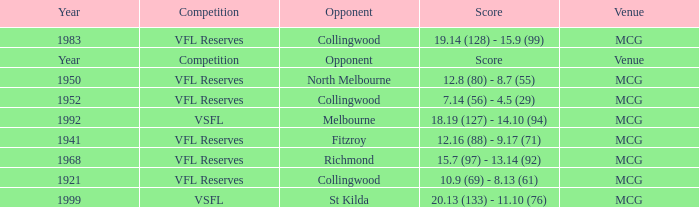At what venue did the team from Collingwood score 7.14 (56) - 4.5 (29)? MCG. Would you mind parsing the complete table? {'header': ['Year', 'Competition', 'Opponent', 'Score', 'Venue'], 'rows': [['1983', 'VFL Reserves', 'Collingwood', '19.14 (128) - 15.9 (99)', 'MCG'], ['Year', 'Competition', 'Opponent', 'Score', 'Venue'], ['1950', 'VFL Reserves', 'North Melbourne', '12.8 (80) - 8.7 (55)', 'MCG'], ['1952', 'VFL Reserves', 'Collingwood', '7.14 (56) - 4.5 (29)', 'MCG'], ['1992', 'VSFL', 'Melbourne', '18.19 (127) - 14.10 (94)', 'MCG'], ['1941', 'VFL Reserves', 'Fitzroy', '12.16 (88) - 9.17 (71)', 'MCG'], ['1968', 'VFL Reserves', 'Richmond', '15.7 (97) - 13.14 (92)', 'MCG'], ['1921', 'VFL Reserves', 'Collingwood', '10.9 (69) - 8.13 (61)', 'MCG'], ['1999', 'VSFL', 'St Kilda', '20.13 (133) - 11.10 (76)', 'MCG']]} 